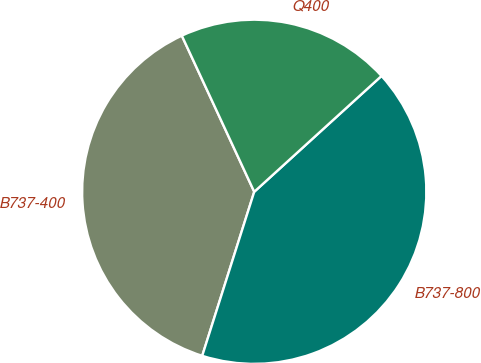Convert chart. <chart><loc_0><loc_0><loc_500><loc_500><pie_chart><fcel>B737-400<fcel>B737-800<fcel>Q400<nl><fcel>38.2%<fcel>41.64%<fcel>20.16%<nl></chart> 